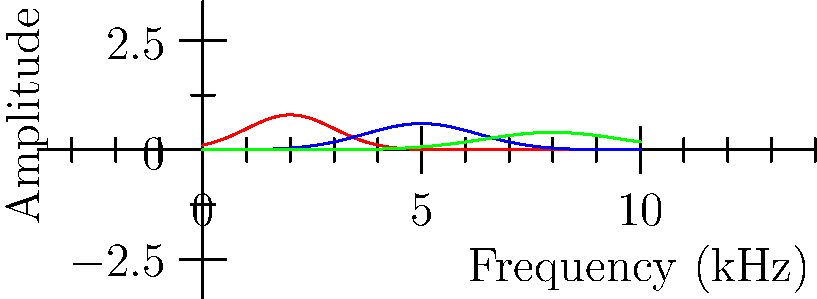In the frequency spectrum shown above, which African vocal technique is represented by the blue curve, and what characteristics of this technique contribute to its unique spectral shape? To answer this question, let's analyze the graph step-by-step:

1. The graph shows three curves representing different African vocal techniques:
   - Red curve: Traditional
   - Blue curve: Ululation
   - Green curve: Overtone

2. The blue curve represents Ululation, which is the technique in question.

3. Characteristics of the Ululation curve:
   a. It has a peak frequency around 5 kHz.
   b. The curve is narrower than the traditional technique (red) but wider than the overtone technique (green).
   c. Its amplitude is between that of the traditional and overtone techniques.

4. These characteristics reflect the nature of Ululation:
   a. Ululation is a high-pitched, trilling sound produced by rapid movement of the tongue and uvula.
   b. The higher peak frequency (compared to traditional singing) corresponds to the higher pitch of Ululation.
   c. The moderate bandwidth suggests a mix of tonal and noise-like components, typical of the rapid modulation in Ululation.
   d. The intermediate amplitude indicates that Ululation is usually performed with moderate intensity, balancing power and control.

5. The unique spectral shape of Ululation is due to:
   a. Rapid amplitude modulation caused by the tongue and uvula movement.
   b. Higher fundamental frequency and harmonics compared to normal speech or singing.
   c. A mix of tonal (harmonic) and noise-like (broadband) components due to the trilling effect.
Answer: Ululation; rapid tongue/uvula movement, high pitch, and amplitude modulation 